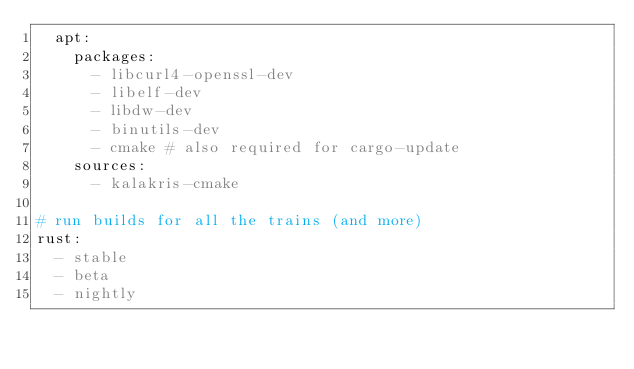Convert code to text. <code><loc_0><loc_0><loc_500><loc_500><_YAML_>  apt:
    packages:
      - libcurl4-openssl-dev
      - libelf-dev
      - libdw-dev
      - binutils-dev
      - cmake # also required for cargo-update
    sources:
      - kalakris-cmake

# run builds for all the trains (and more)
rust:
  - stable
  - beta
  - nightly
</code> 